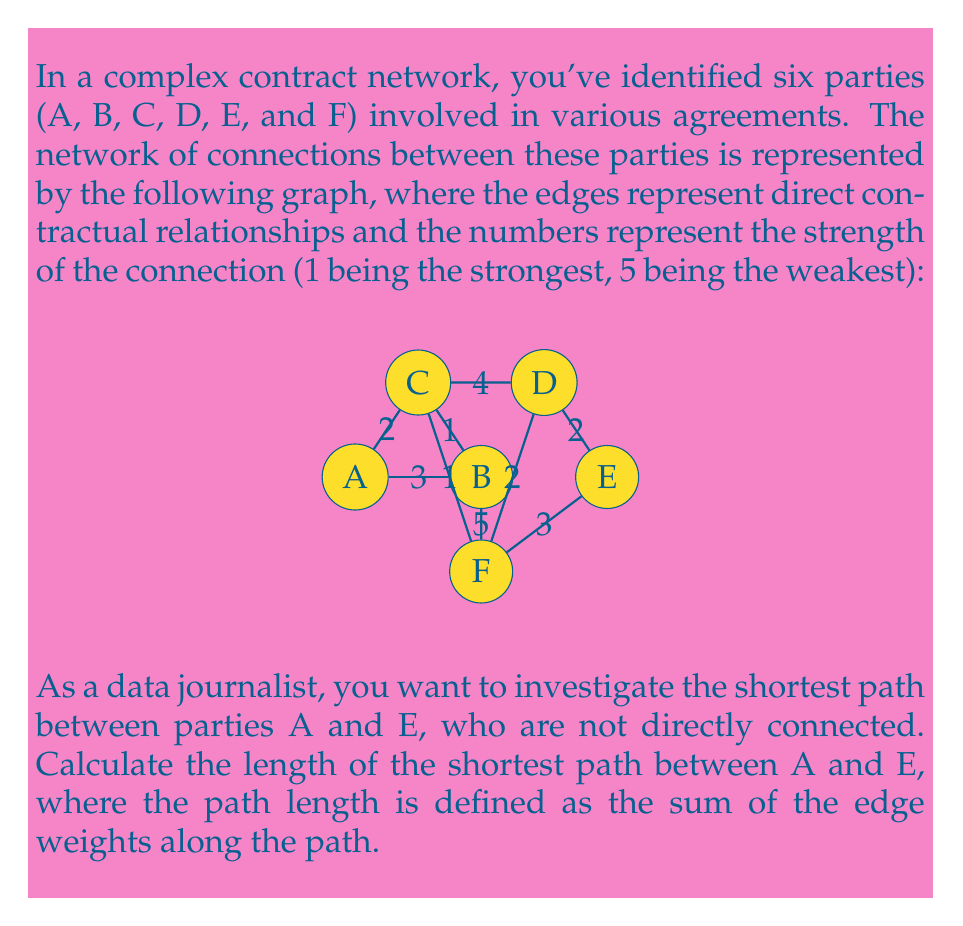Show me your answer to this math problem. To solve this problem, we need to consider all possible paths from A to E and calculate their lengths. Then, we'll choose the path with the smallest total length. Let's break it down step-by-step:

1) First, let's identify all possible paths from A to E:
   Path 1: A -> B -> E
   Path 2: A -> C -> D -> E
   Path 3: A -> C -> F -> E
   Path 4: A -> B -> F -> E
   Path 5: A -> C -> F -> B -> E

2) Now, let's calculate the length of each path:

   Path 1: A -> B -> E
   Length = 3 + 5 = 8

   Path 2: A -> C -> D -> E
   Length = 2 + 4 + 2 = 8

   Path 3: A -> C -> F -> E
   Length = 2 + 1 + 3 = 6

   Path 4: A -> B -> F -> E
   Length = 3 + 5 + 3 = 11

   Path 5: A -> C -> F -> B -> E
   Length = 2 + 1 + 5 + 5 = 13

3) The shortest path is the one with the smallest total length. From our calculations, we can see that Path 3 (A -> C -> F -> E) has the shortest length of 6.

Therefore, the shortest path between A and E has a length of 6.
Answer: 6 